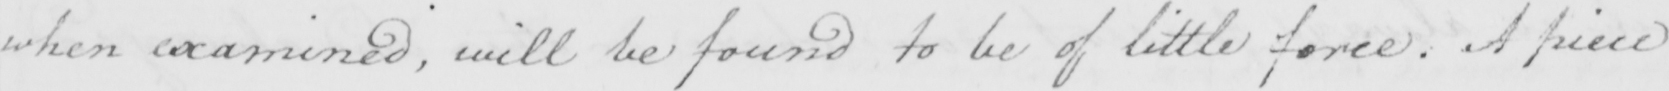Transcribe the text shown in this historical manuscript line. when examined , will be found to be of little force . A piece 